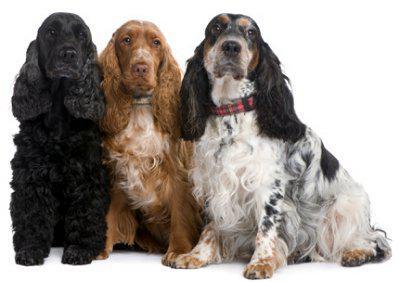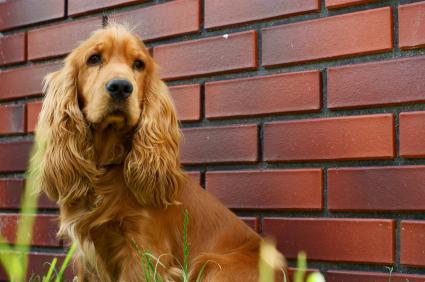The first image is the image on the left, the second image is the image on the right. Analyze the images presented: Is the assertion "There are no fewer than two dogs out doors in the image on the left." valid? Answer yes or no. No. The first image is the image on the left, the second image is the image on the right. For the images shown, is this caption "At least three dogs, all of them the same breed, but different colors, are in one image." true? Answer yes or no. Yes. 